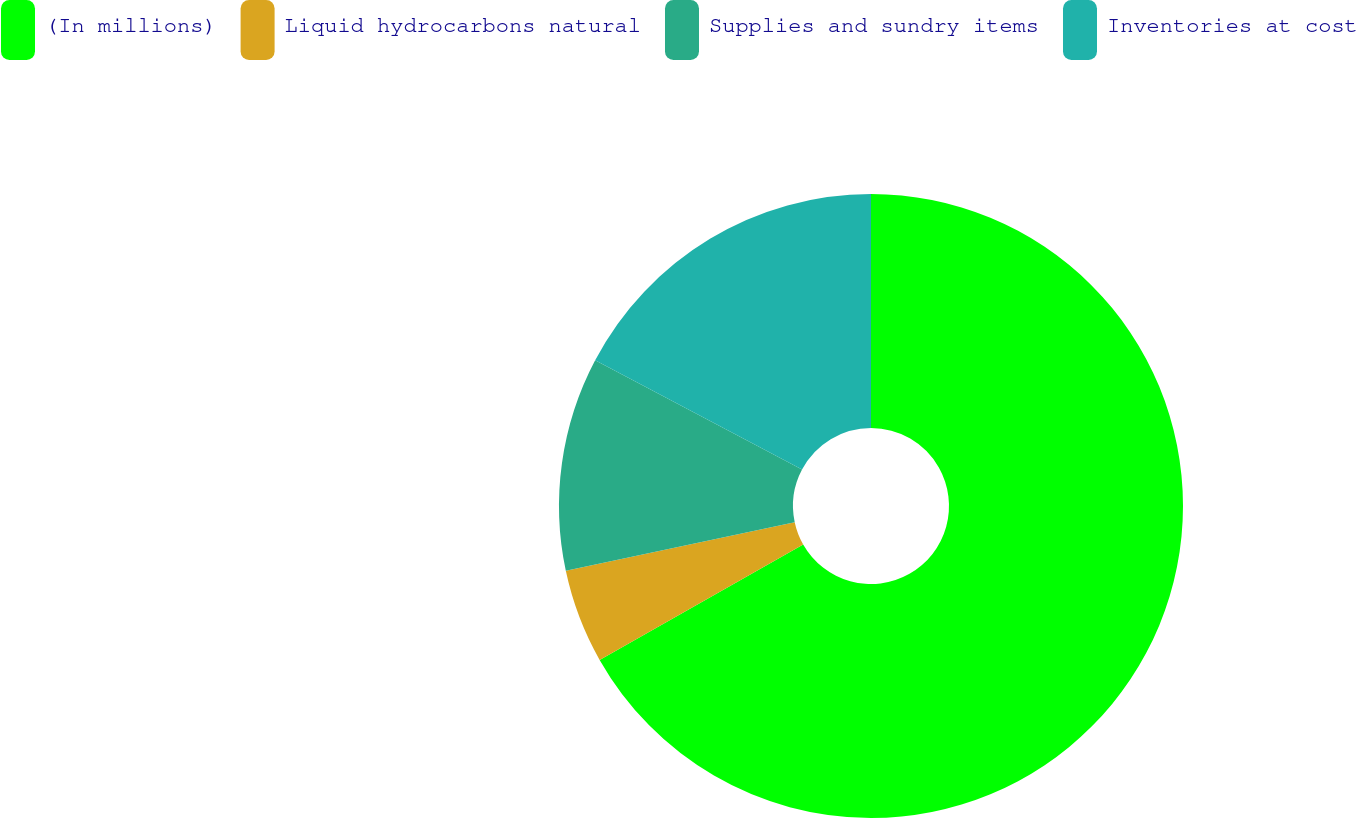Convert chart to OTSL. <chart><loc_0><loc_0><loc_500><loc_500><pie_chart><fcel>(In millions)<fcel>Liquid hydrocarbons natural<fcel>Supplies and sundry items<fcel>Inventories at cost<nl><fcel>66.78%<fcel>4.88%<fcel>11.07%<fcel>17.26%<nl></chart> 